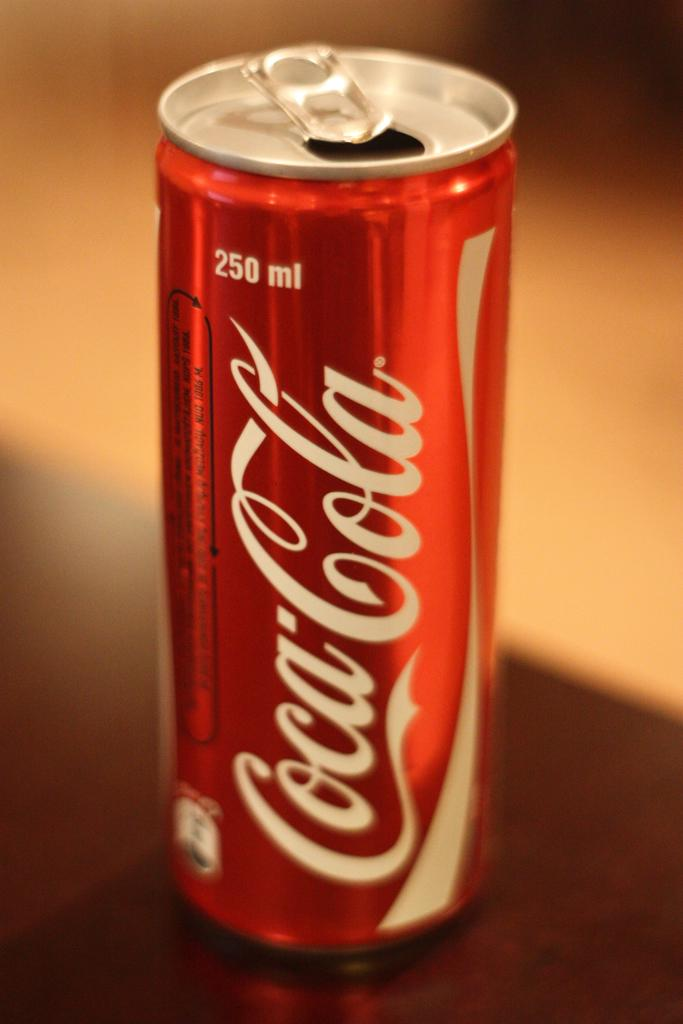<image>
Summarize the visual content of the image. An open 250 ml can of Coca Cola sits on a table. 